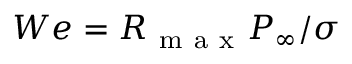Convert formula to latex. <formula><loc_0><loc_0><loc_500><loc_500>W e = R _ { m a x } P _ { \infty } / \sigma</formula> 